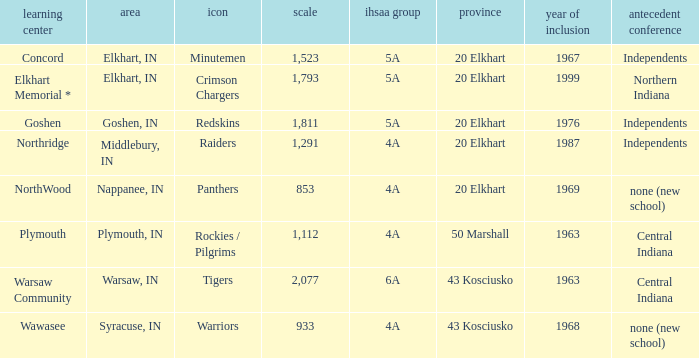What is the IHSAA class for the team located in Middlebury, IN? 4A. 